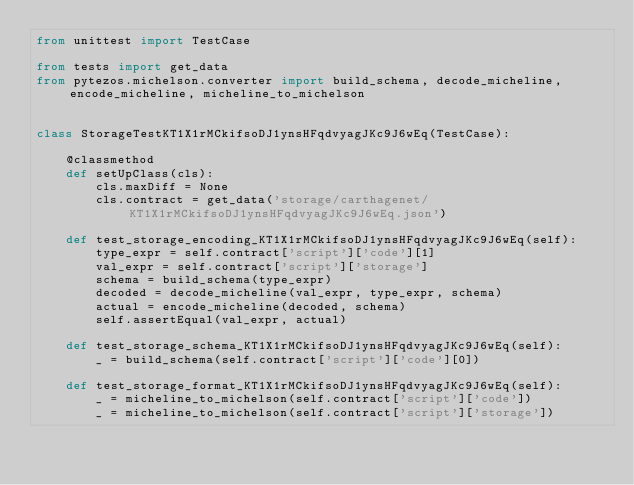<code> <loc_0><loc_0><loc_500><loc_500><_Python_>from unittest import TestCase

from tests import get_data
from pytezos.michelson.converter import build_schema, decode_micheline, encode_micheline, micheline_to_michelson


class StorageTestKT1X1rMCkifsoDJ1ynsHFqdvyagJKc9J6wEq(TestCase):

    @classmethod
    def setUpClass(cls):
        cls.maxDiff = None
        cls.contract = get_data('storage/carthagenet/KT1X1rMCkifsoDJ1ynsHFqdvyagJKc9J6wEq.json')

    def test_storage_encoding_KT1X1rMCkifsoDJ1ynsHFqdvyagJKc9J6wEq(self):
        type_expr = self.contract['script']['code'][1]
        val_expr = self.contract['script']['storage']
        schema = build_schema(type_expr)
        decoded = decode_micheline(val_expr, type_expr, schema)
        actual = encode_micheline(decoded, schema)
        self.assertEqual(val_expr, actual)

    def test_storage_schema_KT1X1rMCkifsoDJ1ynsHFqdvyagJKc9J6wEq(self):
        _ = build_schema(self.contract['script']['code'][0])

    def test_storage_format_KT1X1rMCkifsoDJ1ynsHFqdvyagJKc9J6wEq(self):
        _ = micheline_to_michelson(self.contract['script']['code'])
        _ = micheline_to_michelson(self.contract['script']['storage'])
</code> 